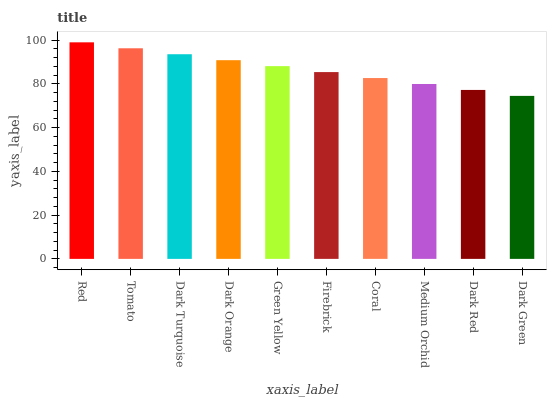Is Dark Green the minimum?
Answer yes or no. Yes. Is Red the maximum?
Answer yes or no. Yes. Is Tomato the minimum?
Answer yes or no. No. Is Tomato the maximum?
Answer yes or no. No. Is Red greater than Tomato?
Answer yes or no. Yes. Is Tomato less than Red?
Answer yes or no. Yes. Is Tomato greater than Red?
Answer yes or no. No. Is Red less than Tomato?
Answer yes or no. No. Is Green Yellow the high median?
Answer yes or no. Yes. Is Firebrick the low median?
Answer yes or no. Yes. Is Dark Orange the high median?
Answer yes or no. No. Is Coral the low median?
Answer yes or no. No. 